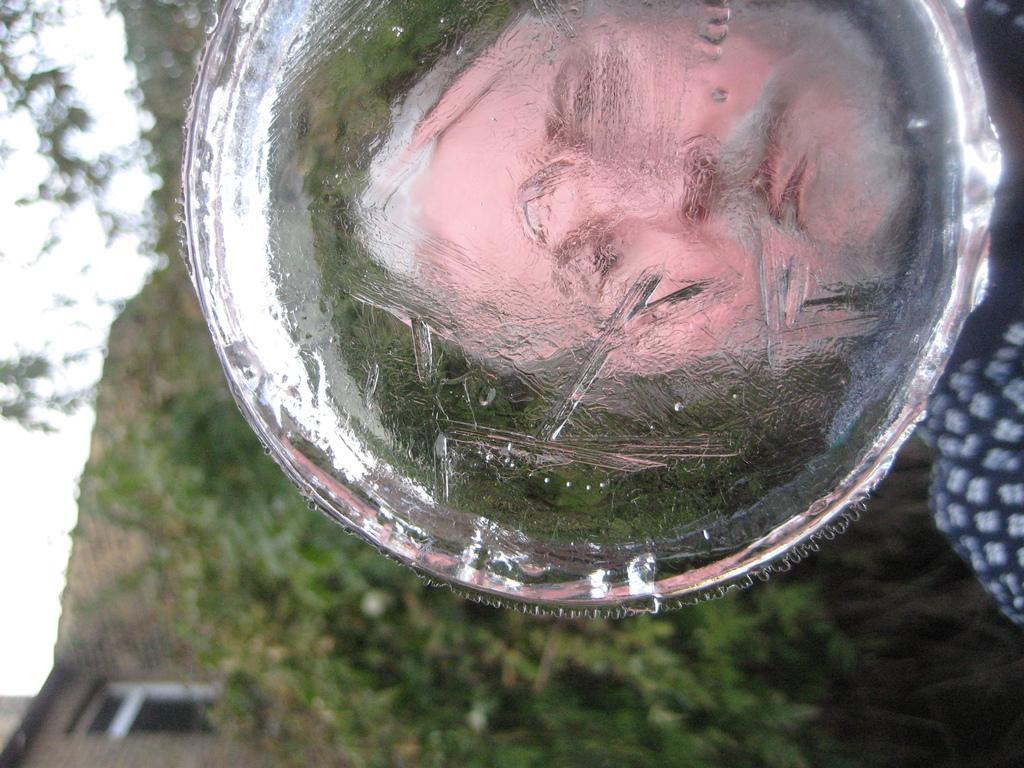Can you describe this image briefly? In this image we can see the face of a woman reflected on the ice. On the backside we can see some trees, a house with window and the sky. 